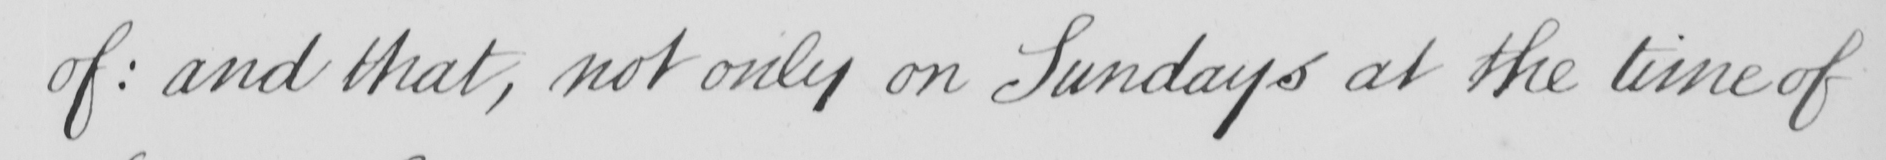Can you read and transcribe this handwriting? of :  and that , not only on Sundays at the time of 